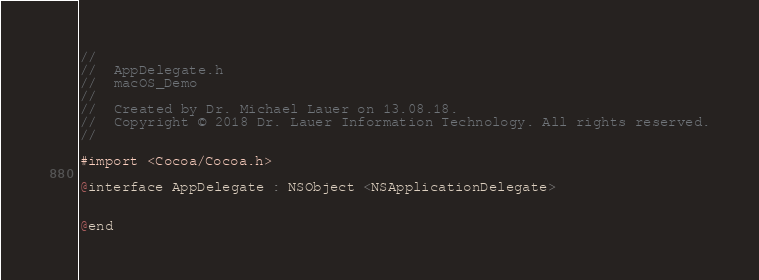<code> <loc_0><loc_0><loc_500><loc_500><_C_>//
//  AppDelegate.h
//  macOS_Demo
//
//  Created by Dr. Michael Lauer on 13.08.18.
//  Copyright © 2018 Dr. Lauer Information Technology. All rights reserved.
//

#import <Cocoa/Cocoa.h>

@interface AppDelegate : NSObject <NSApplicationDelegate>


@end

</code> 